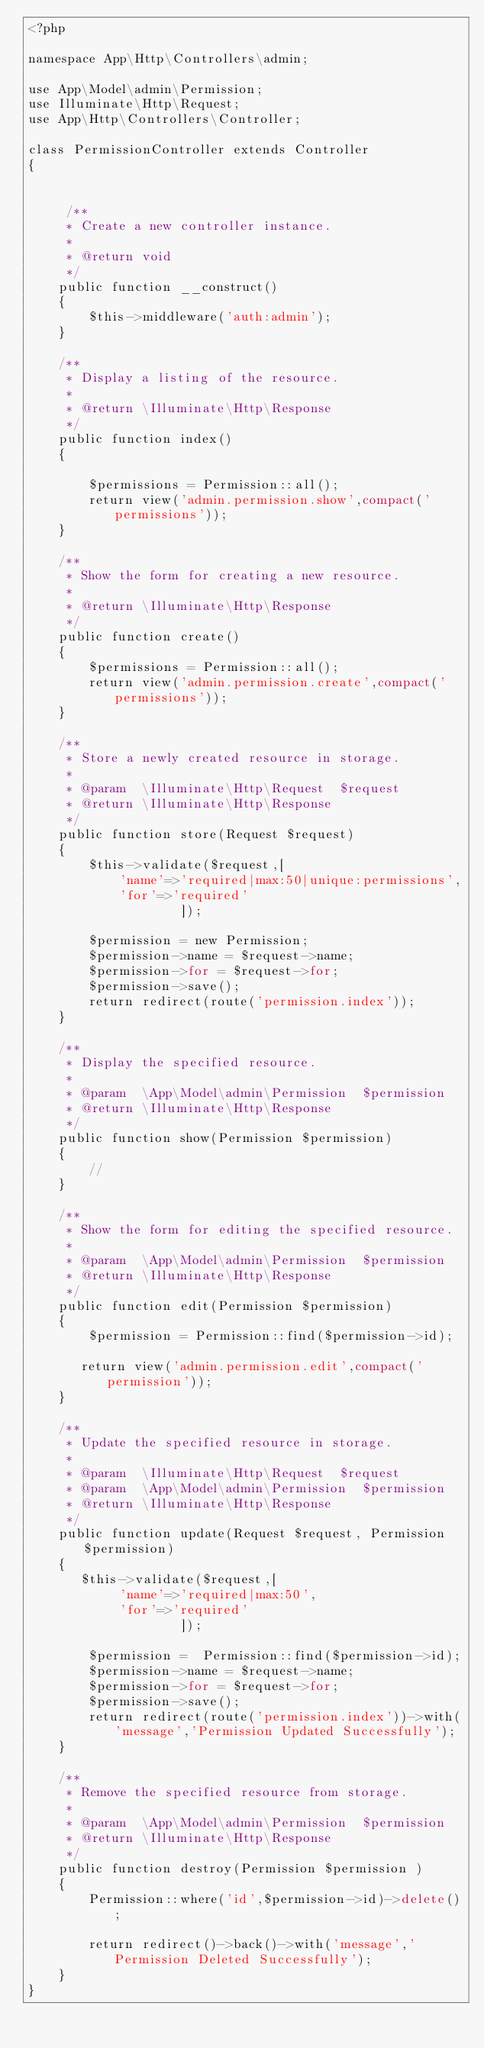<code> <loc_0><loc_0><loc_500><loc_500><_PHP_><?php

namespace App\Http\Controllers\admin;

use App\Model\admin\Permission;
use Illuminate\Http\Request;
use App\Http\Controllers\Controller;

class PermissionController extends Controller
{


     /**
     * Create a new controller instance.
     *
     * @return void
     */
    public function __construct()
    {
        $this->middleware('auth:admin');
    }
    
    /**
     * Display a listing of the resource.
     *
     * @return \Illuminate\Http\Response
     */
    public function index()
    {

        $permissions = Permission::all();
        return view('admin.permission.show',compact('permissions'));
    }

    /**
     * Show the form for creating a new resource.
     *
     * @return \Illuminate\Http\Response
     */
    public function create()
    {
        $permissions = Permission::all(); 
        return view('admin.permission.create',compact('permissions'));
    }

    /**
     * Store a newly created resource in storage.
     *
     * @param  \Illuminate\Http\Request  $request
     * @return \Illuminate\Http\Response
     */
    public function store(Request $request)
    {
        $this->validate($request,[
            'name'=>'required|max:50|unique:permissions',
            'for'=>'required'
                    ]);

        $permission = new Permission;
        $permission->name = $request->name;
        $permission->for = $request->for;
        $permission->save();
        return redirect(route('permission.index'));
    }

    /**
     * Display the specified resource.
     *
     * @param  \App\Model\admin\Permission  $permission
     * @return \Illuminate\Http\Response
     */
    public function show(Permission $permission)
    {
        //
    }

    /**
     * Show the form for editing the specified resource.
     *
     * @param  \App\Model\admin\Permission  $permission
     * @return \Illuminate\Http\Response
     */
    public function edit(Permission $permission)
    {
        $permission = Permission::find($permission->id);

       return view('admin.permission.edit',compact('permission'));
    }

    /**
     * Update the specified resource in storage.
     *
     * @param  \Illuminate\Http\Request  $request
     * @param  \App\Model\admin\Permission  $permission
     * @return \Illuminate\Http\Response
     */
    public function update(Request $request, Permission $permission)
    {
       $this->validate($request,[
            'name'=>'required|max:50',
            'for'=>'required'
                    ]);

        $permission =  Permission::find($permission->id);
        $permission->name = $request->name;
        $permission->for = $request->for;
        $permission->save();
        return redirect(route('permission.index'))->with('message','Permission Updated Successfully');
    }

    /**
     * Remove the specified resource from storage.
     *
     * @param  \App\Model\admin\Permission  $permission
     * @return \Illuminate\Http\Response
     */
    public function destroy(Permission $permission )
    {
        Permission::where('id',$permission->id)->delete();

        return redirect()->back()->with('message','Permission Deleted Successfully');
    }
}
</code> 